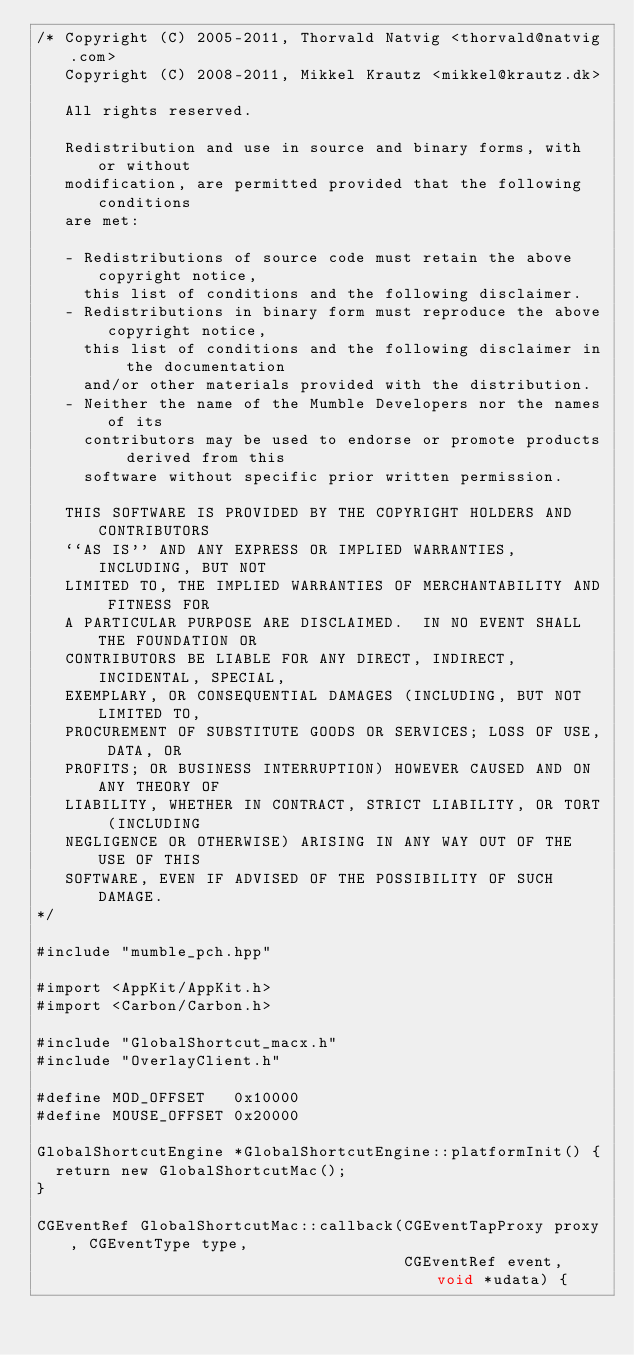<code> <loc_0><loc_0><loc_500><loc_500><_ObjectiveC_>/* Copyright (C) 2005-2011, Thorvald Natvig <thorvald@natvig.com>
   Copyright (C) 2008-2011, Mikkel Krautz <mikkel@krautz.dk>

   All rights reserved.

   Redistribution and use in source and binary forms, with or without
   modification, are permitted provided that the following conditions
   are met:

   - Redistributions of source code must retain the above copyright notice,
     this list of conditions and the following disclaimer.
   - Redistributions in binary form must reproduce the above copyright notice,
     this list of conditions and the following disclaimer in the documentation
     and/or other materials provided with the distribution.
   - Neither the name of the Mumble Developers nor the names of its
     contributors may be used to endorse or promote products derived from this
     software without specific prior written permission.

   THIS SOFTWARE IS PROVIDED BY THE COPYRIGHT HOLDERS AND CONTRIBUTORS
   ``AS IS'' AND ANY EXPRESS OR IMPLIED WARRANTIES, INCLUDING, BUT NOT
   LIMITED TO, THE IMPLIED WARRANTIES OF MERCHANTABILITY AND FITNESS FOR
   A PARTICULAR PURPOSE ARE DISCLAIMED.  IN NO EVENT SHALL THE FOUNDATION OR
   CONTRIBUTORS BE LIABLE FOR ANY DIRECT, INDIRECT, INCIDENTAL, SPECIAL,
   EXEMPLARY, OR CONSEQUENTIAL DAMAGES (INCLUDING, BUT NOT LIMITED TO,
   PROCUREMENT OF SUBSTITUTE GOODS OR SERVICES; LOSS OF USE, DATA, OR
   PROFITS; OR BUSINESS INTERRUPTION) HOWEVER CAUSED AND ON ANY THEORY OF
   LIABILITY, WHETHER IN CONTRACT, STRICT LIABILITY, OR TORT (INCLUDING
   NEGLIGENCE OR OTHERWISE) ARISING IN ANY WAY OUT OF THE USE OF THIS
   SOFTWARE, EVEN IF ADVISED OF THE POSSIBILITY OF SUCH DAMAGE.
*/

#include "mumble_pch.hpp"

#import <AppKit/AppKit.h>
#import <Carbon/Carbon.h>

#include "GlobalShortcut_macx.h"
#include "OverlayClient.h"

#define MOD_OFFSET   0x10000
#define MOUSE_OFFSET 0x20000

GlobalShortcutEngine *GlobalShortcutEngine::platformInit() {
	return new GlobalShortcutMac();
}

CGEventRef GlobalShortcutMac::callback(CGEventTapProxy proxy, CGEventType type,
                                       CGEventRef event, void *udata) {</code> 